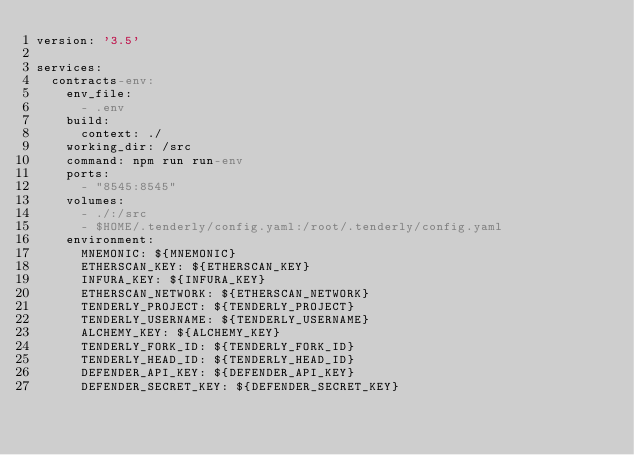<code> <loc_0><loc_0><loc_500><loc_500><_YAML_>version: '3.5'

services:
  contracts-env:
    env_file:
      - .env
    build:
      context: ./
    working_dir: /src
    command: npm run run-env
    ports:
      - "8545:8545"
    volumes:
      - ./:/src
      - $HOME/.tenderly/config.yaml:/root/.tenderly/config.yaml
    environment:
      MNEMONIC: ${MNEMONIC}
      ETHERSCAN_KEY: ${ETHERSCAN_KEY}
      INFURA_KEY: ${INFURA_KEY}
      ETHERSCAN_NETWORK: ${ETHERSCAN_NETWORK}
      TENDERLY_PROJECT: ${TENDERLY_PROJECT}
      TENDERLY_USERNAME: ${TENDERLY_USERNAME}
      ALCHEMY_KEY: ${ALCHEMY_KEY}
      TENDERLY_FORK_ID: ${TENDERLY_FORK_ID}
      TENDERLY_HEAD_ID: ${TENDERLY_HEAD_ID}
      DEFENDER_API_KEY: ${DEFENDER_API_KEY}
      DEFENDER_SECRET_KEY: ${DEFENDER_SECRET_KEY}
</code> 